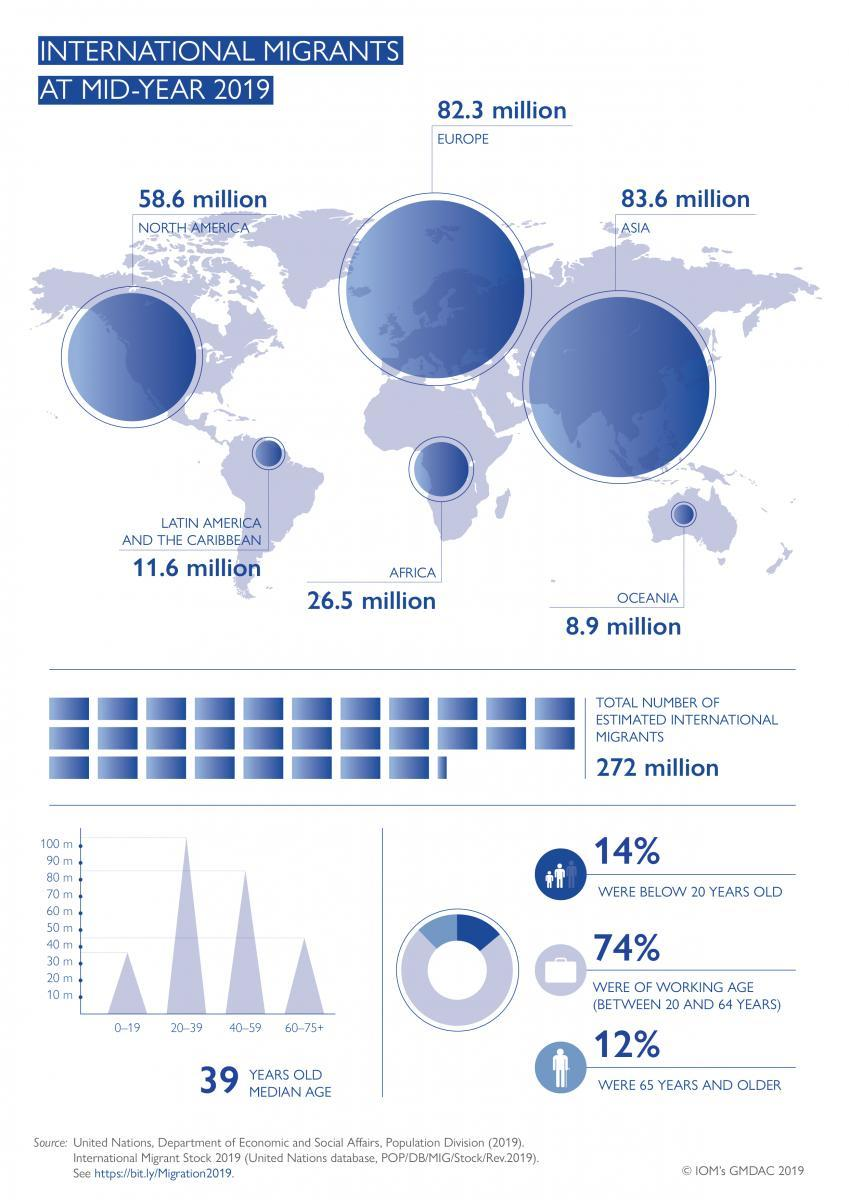What is the second largest age group among the migrants?
Answer the question with a short phrase. 40-59 What are the total migrants in Oceania and Europe at mid-year 2019? 91.2 million What are the total migrants in Asia and Europe at mid-year 2019? 165.9 million What are the total migrants in North America and Latin America and the Caribbean at mid-year 2019? 70.2 million What is the third largest age group among the migrants? 60-75+ What are the total migrants in North America and Europe at mid-year 2019? 140.9 million 